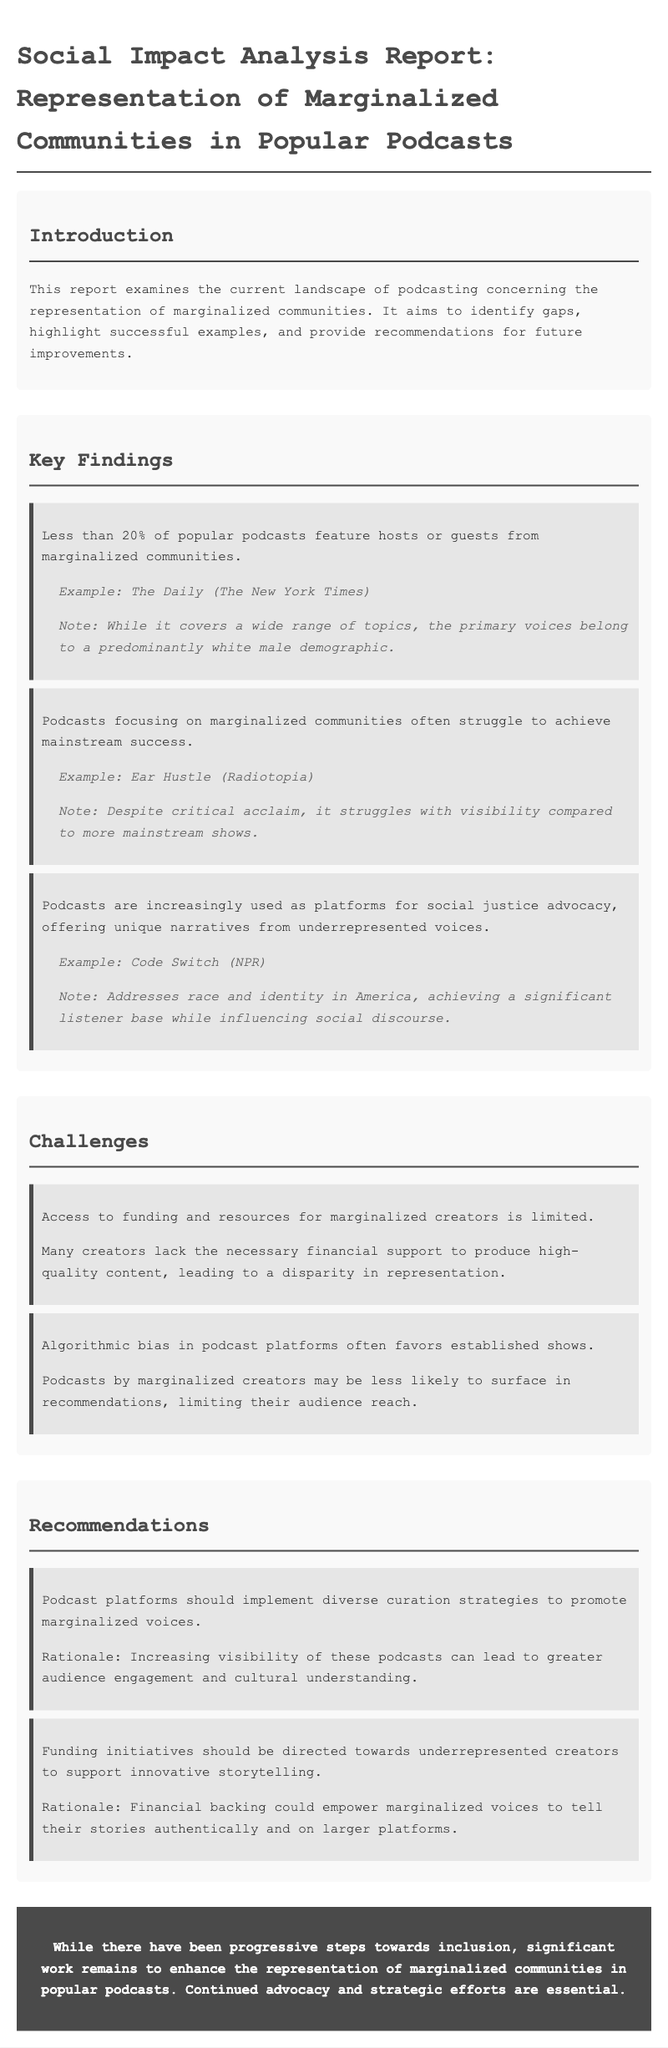What percentage of popular podcasts feature hosts or guests from marginalized communities? The report states that less than 20% of popular podcasts feature hosts or guests from marginalized communities.
Answer: Less than 20% What is an example of a podcast that struggles with visibility despite critical acclaim? The document mentions "Ear Hustle" as a podcast that, despite its acclaim, struggles with visibility compared to mainstream shows.
Answer: Ear Hustle What is one key challenge mentioned regarding access for marginalized creators? The report highlights that access to funding and resources for marginalized creators is limited, leading to a disparity in representation.
Answer: Limited access to funding Which podcast addresses race and identity in America? The document identifies "Code Switch" by NPR as a podcast that addresses race and identity in America.
Answer: Code Switch What recommendation does the report provide for podcast platforms? One recommendation is that podcast platforms should implement diverse curation strategies to promote marginalized voices.
Answer: Diverse curation strategies What is a rationale for funding initiatives directed towards underrepresented creators? The report suggests that financial backing could empower marginalized voices to tell their stories authentically and on larger platforms.
Answer: Empower marginalized voices What is the conclusion of the report's findings? The conclusion emphasizes that while there have been progressive steps, significant work remains to enhance representation in podcasts.
Answer: Significant work remains What type of podcasts often struggle to achieve mainstream success? The report states that podcasts focusing on marginalized communities often struggle to achieve mainstream success.
Answer: Marginalized communities What is a notable effect of algorithmic bias mentioned in the document? According to the report, algorithmic bias in podcast platforms often favors established shows, limiting audience reach for podcasts by marginalized creators.
Answer: Favor established shows 